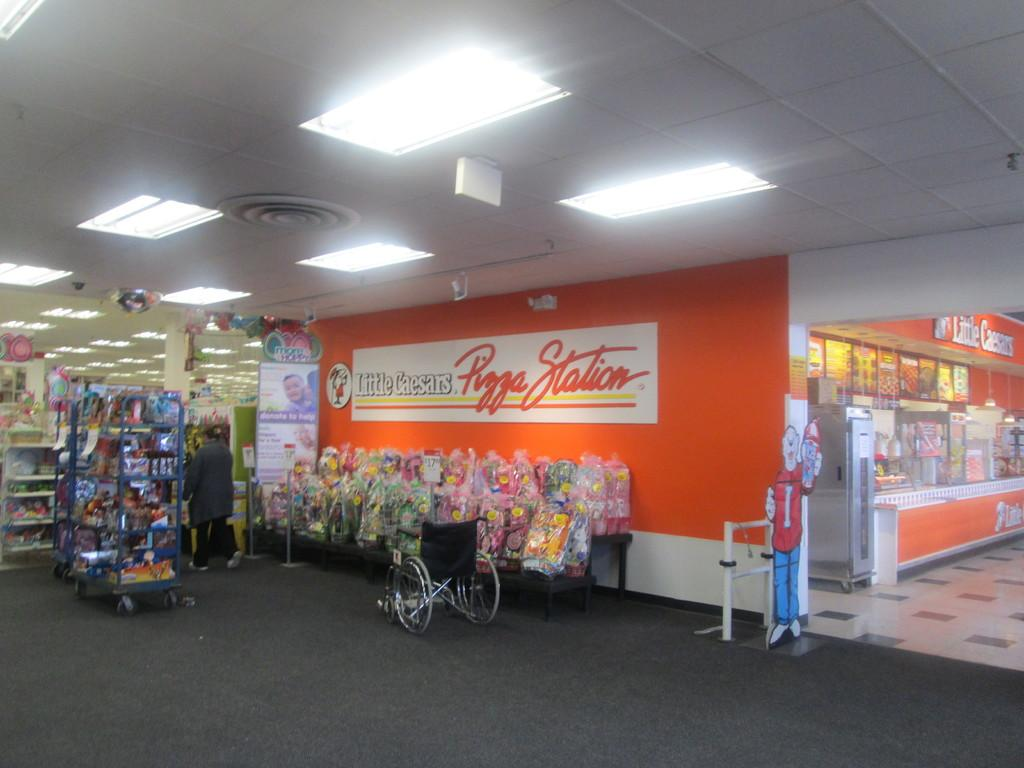<image>
Provide a brief description of the given image. A wheelchair is next to a display in a store near the wall of Little Caesars Pizza restaurant. 